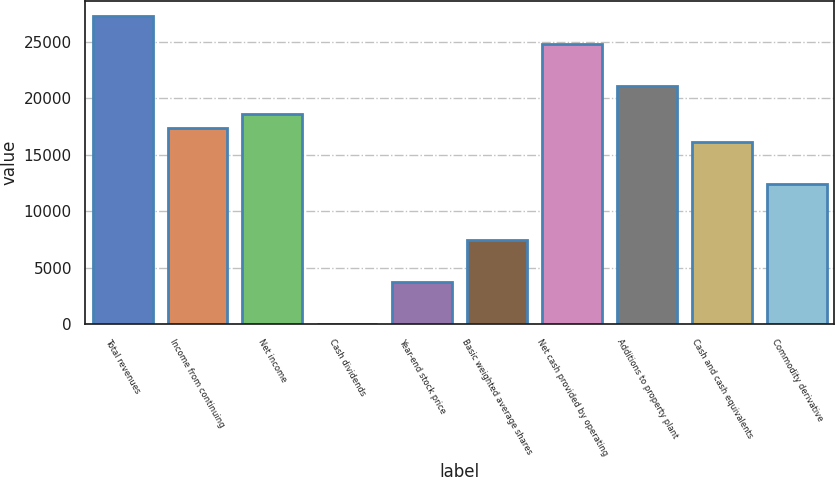<chart> <loc_0><loc_0><loc_500><loc_500><bar_chart><fcel>Total revenues<fcel>Income from continuing<fcel>Net income<fcel>Cash dividends<fcel>Year-end stock price<fcel>Basic weighted average shares<fcel>Net cash provided by operating<fcel>Additions to property plant<fcel>Cash and cash equivalents<fcel>Commodity derivative<nl><fcel>27243.9<fcel>17337.3<fcel>18575.6<fcel>0.66<fcel>3715.65<fcel>7430.64<fcel>24767.3<fcel>21052.3<fcel>16099<fcel>12384<nl></chart> 